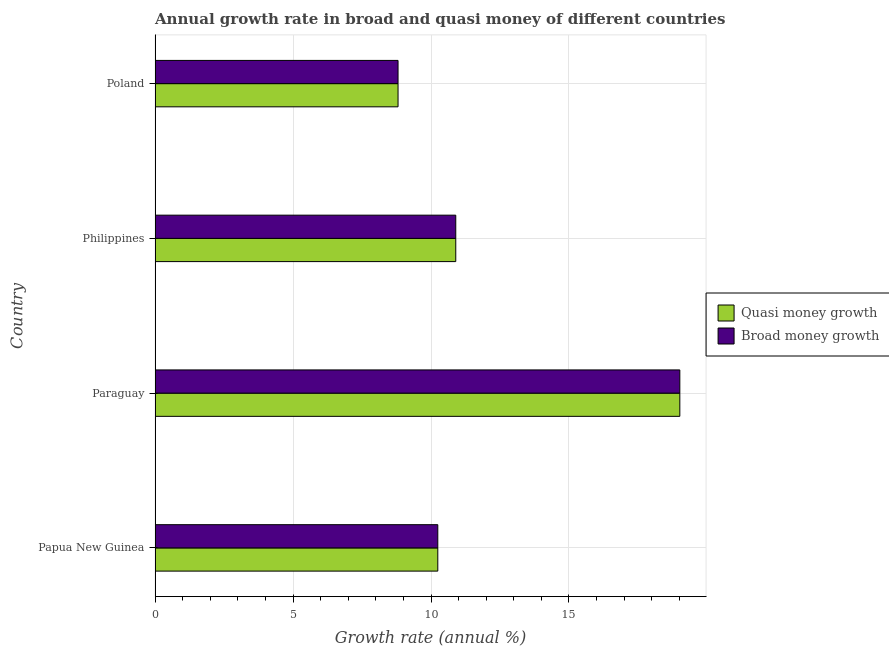How many groups of bars are there?
Your response must be concise. 4. Are the number of bars on each tick of the Y-axis equal?
Your answer should be compact. Yes. How many bars are there on the 3rd tick from the bottom?
Your response must be concise. 2. What is the label of the 3rd group of bars from the top?
Provide a succinct answer. Paraguay. What is the annual growth rate in broad money in Paraguay?
Give a very brief answer. 19.02. Across all countries, what is the maximum annual growth rate in quasi money?
Your answer should be compact. 19.02. Across all countries, what is the minimum annual growth rate in quasi money?
Your answer should be compact. 8.81. In which country was the annual growth rate in quasi money maximum?
Provide a short and direct response. Paraguay. What is the total annual growth rate in broad money in the graph?
Keep it short and to the point. 48.97. What is the difference between the annual growth rate in quasi money in Paraguay and that in Philippines?
Give a very brief answer. 8.12. What is the difference between the annual growth rate in quasi money in Philippines and the annual growth rate in broad money in Papua New Guinea?
Ensure brevity in your answer.  0.65. What is the average annual growth rate in broad money per country?
Your answer should be compact. 12.24. In how many countries, is the annual growth rate in quasi money greater than 13 %?
Ensure brevity in your answer.  1. What is the ratio of the annual growth rate in quasi money in Paraguay to that in Poland?
Your answer should be very brief. 2.16. Is the difference between the annual growth rate in broad money in Papua New Guinea and Paraguay greater than the difference between the annual growth rate in quasi money in Papua New Guinea and Paraguay?
Offer a terse response. No. What is the difference between the highest and the second highest annual growth rate in quasi money?
Ensure brevity in your answer.  8.12. What is the difference between the highest and the lowest annual growth rate in quasi money?
Provide a succinct answer. 10.21. In how many countries, is the annual growth rate in quasi money greater than the average annual growth rate in quasi money taken over all countries?
Your answer should be very brief. 1. Is the sum of the annual growth rate in broad money in Paraguay and Poland greater than the maximum annual growth rate in quasi money across all countries?
Offer a terse response. Yes. What does the 2nd bar from the top in Paraguay represents?
Your answer should be very brief. Quasi money growth. What does the 2nd bar from the bottom in Philippines represents?
Ensure brevity in your answer.  Broad money growth. How many bars are there?
Your answer should be very brief. 8. Are all the bars in the graph horizontal?
Make the answer very short. Yes. How many countries are there in the graph?
Provide a succinct answer. 4. What is the difference between two consecutive major ticks on the X-axis?
Give a very brief answer. 5. Are the values on the major ticks of X-axis written in scientific E-notation?
Provide a short and direct response. No. Where does the legend appear in the graph?
Your response must be concise. Center right. How are the legend labels stacked?
Offer a very short reply. Vertical. What is the title of the graph?
Ensure brevity in your answer.  Annual growth rate in broad and quasi money of different countries. What is the label or title of the X-axis?
Offer a very short reply. Growth rate (annual %). What is the Growth rate (annual %) of Quasi money growth in Papua New Guinea?
Your response must be concise. 10.25. What is the Growth rate (annual %) of Broad money growth in Papua New Guinea?
Make the answer very short. 10.25. What is the Growth rate (annual %) of Quasi money growth in Paraguay?
Provide a succinct answer. 19.02. What is the Growth rate (annual %) in Broad money growth in Paraguay?
Provide a succinct answer. 19.02. What is the Growth rate (annual %) of Quasi money growth in Philippines?
Make the answer very short. 10.9. What is the Growth rate (annual %) of Broad money growth in Philippines?
Give a very brief answer. 10.9. What is the Growth rate (annual %) of Quasi money growth in Poland?
Provide a short and direct response. 8.81. What is the Growth rate (annual %) in Broad money growth in Poland?
Ensure brevity in your answer.  8.81. Across all countries, what is the maximum Growth rate (annual %) of Quasi money growth?
Offer a terse response. 19.02. Across all countries, what is the maximum Growth rate (annual %) in Broad money growth?
Your answer should be compact. 19.02. Across all countries, what is the minimum Growth rate (annual %) of Quasi money growth?
Give a very brief answer. 8.81. Across all countries, what is the minimum Growth rate (annual %) in Broad money growth?
Provide a succinct answer. 8.81. What is the total Growth rate (annual %) of Quasi money growth in the graph?
Your response must be concise. 48.97. What is the total Growth rate (annual %) of Broad money growth in the graph?
Ensure brevity in your answer.  48.97. What is the difference between the Growth rate (annual %) of Quasi money growth in Papua New Guinea and that in Paraguay?
Your response must be concise. -8.77. What is the difference between the Growth rate (annual %) of Broad money growth in Papua New Guinea and that in Paraguay?
Make the answer very short. -8.77. What is the difference between the Growth rate (annual %) in Quasi money growth in Papua New Guinea and that in Philippines?
Provide a succinct answer. -0.65. What is the difference between the Growth rate (annual %) of Broad money growth in Papua New Guinea and that in Philippines?
Ensure brevity in your answer.  -0.65. What is the difference between the Growth rate (annual %) of Quasi money growth in Papua New Guinea and that in Poland?
Your answer should be compact. 1.44. What is the difference between the Growth rate (annual %) of Broad money growth in Papua New Guinea and that in Poland?
Ensure brevity in your answer.  1.44. What is the difference between the Growth rate (annual %) in Quasi money growth in Paraguay and that in Philippines?
Ensure brevity in your answer.  8.12. What is the difference between the Growth rate (annual %) of Broad money growth in Paraguay and that in Philippines?
Offer a terse response. 8.12. What is the difference between the Growth rate (annual %) in Quasi money growth in Paraguay and that in Poland?
Your response must be concise. 10.21. What is the difference between the Growth rate (annual %) of Broad money growth in Paraguay and that in Poland?
Give a very brief answer. 10.21. What is the difference between the Growth rate (annual %) in Quasi money growth in Philippines and that in Poland?
Provide a succinct answer. 2.09. What is the difference between the Growth rate (annual %) of Broad money growth in Philippines and that in Poland?
Make the answer very short. 2.09. What is the difference between the Growth rate (annual %) in Quasi money growth in Papua New Guinea and the Growth rate (annual %) in Broad money growth in Paraguay?
Your answer should be very brief. -8.77. What is the difference between the Growth rate (annual %) in Quasi money growth in Papua New Guinea and the Growth rate (annual %) in Broad money growth in Philippines?
Provide a succinct answer. -0.65. What is the difference between the Growth rate (annual %) in Quasi money growth in Papua New Guinea and the Growth rate (annual %) in Broad money growth in Poland?
Offer a terse response. 1.44. What is the difference between the Growth rate (annual %) of Quasi money growth in Paraguay and the Growth rate (annual %) of Broad money growth in Philippines?
Offer a terse response. 8.12. What is the difference between the Growth rate (annual %) of Quasi money growth in Paraguay and the Growth rate (annual %) of Broad money growth in Poland?
Offer a terse response. 10.21. What is the difference between the Growth rate (annual %) in Quasi money growth in Philippines and the Growth rate (annual %) in Broad money growth in Poland?
Offer a terse response. 2.09. What is the average Growth rate (annual %) in Quasi money growth per country?
Your response must be concise. 12.24. What is the average Growth rate (annual %) of Broad money growth per country?
Provide a short and direct response. 12.24. What is the difference between the Growth rate (annual %) of Quasi money growth and Growth rate (annual %) of Broad money growth in Philippines?
Your answer should be very brief. 0. What is the ratio of the Growth rate (annual %) of Quasi money growth in Papua New Guinea to that in Paraguay?
Offer a very short reply. 0.54. What is the ratio of the Growth rate (annual %) in Broad money growth in Papua New Guinea to that in Paraguay?
Your answer should be compact. 0.54. What is the ratio of the Growth rate (annual %) of Quasi money growth in Papua New Guinea to that in Philippines?
Give a very brief answer. 0.94. What is the ratio of the Growth rate (annual %) in Broad money growth in Papua New Guinea to that in Philippines?
Provide a short and direct response. 0.94. What is the ratio of the Growth rate (annual %) of Quasi money growth in Papua New Guinea to that in Poland?
Provide a succinct answer. 1.16. What is the ratio of the Growth rate (annual %) in Broad money growth in Papua New Guinea to that in Poland?
Provide a short and direct response. 1.16. What is the ratio of the Growth rate (annual %) in Quasi money growth in Paraguay to that in Philippines?
Ensure brevity in your answer.  1.75. What is the ratio of the Growth rate (annual %) in Broad money growth in Paraguay to that in Philippines?
Keep it short and to the point. 1.75. What is the ratio of the Growth rate (annual %) of Quasi money growth in Paraguay to that in Poland?
Your response must be concise. 2.16. What is the ratio of the Growth rate (annual %) in Broad money growth in Paraguay to that in Poland?
Offer a very short reply. 2.16. What is the ratio of the Growth rate (annual %) in Quasi money growth in Philippines to that in Poland?
Ensure brevity in your answer.  1.24. What is the ratio of the Growth rate (annual %) in Broad money growth in Philippines to that in Poland?
Provide a succinct answer. 1.24. What is the difference between the highest and the second highest Growth rate (annual %) of Quasi money growth?
Provide a succinct answer. 8.12. What is the difference between the highest and the second highest Growth rate (annual %) in Broad money growth?
Your response must be concise. 8.12. What is the difference between the highest and the lowest Growth rate (annual %) in Quasi money growth?
Offer a terse response. 10.21. What is the difference between the highest and the lowest Growth rate (annual %) in Broad money growth?
Your answer should be compact. 10.21. 